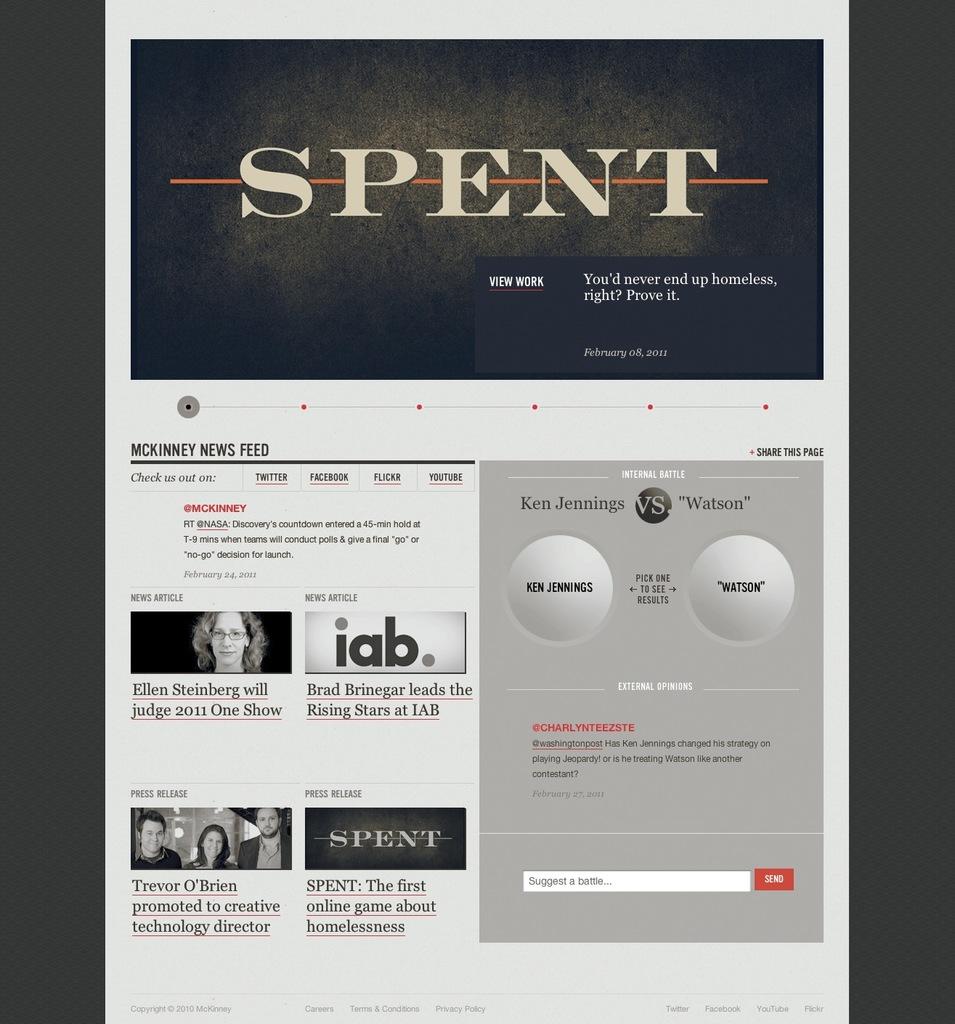What does the top of the page say?
Your answer should be compact. Spent. Who is versus watson?
Keep it short and to the point. Ken jennings. 